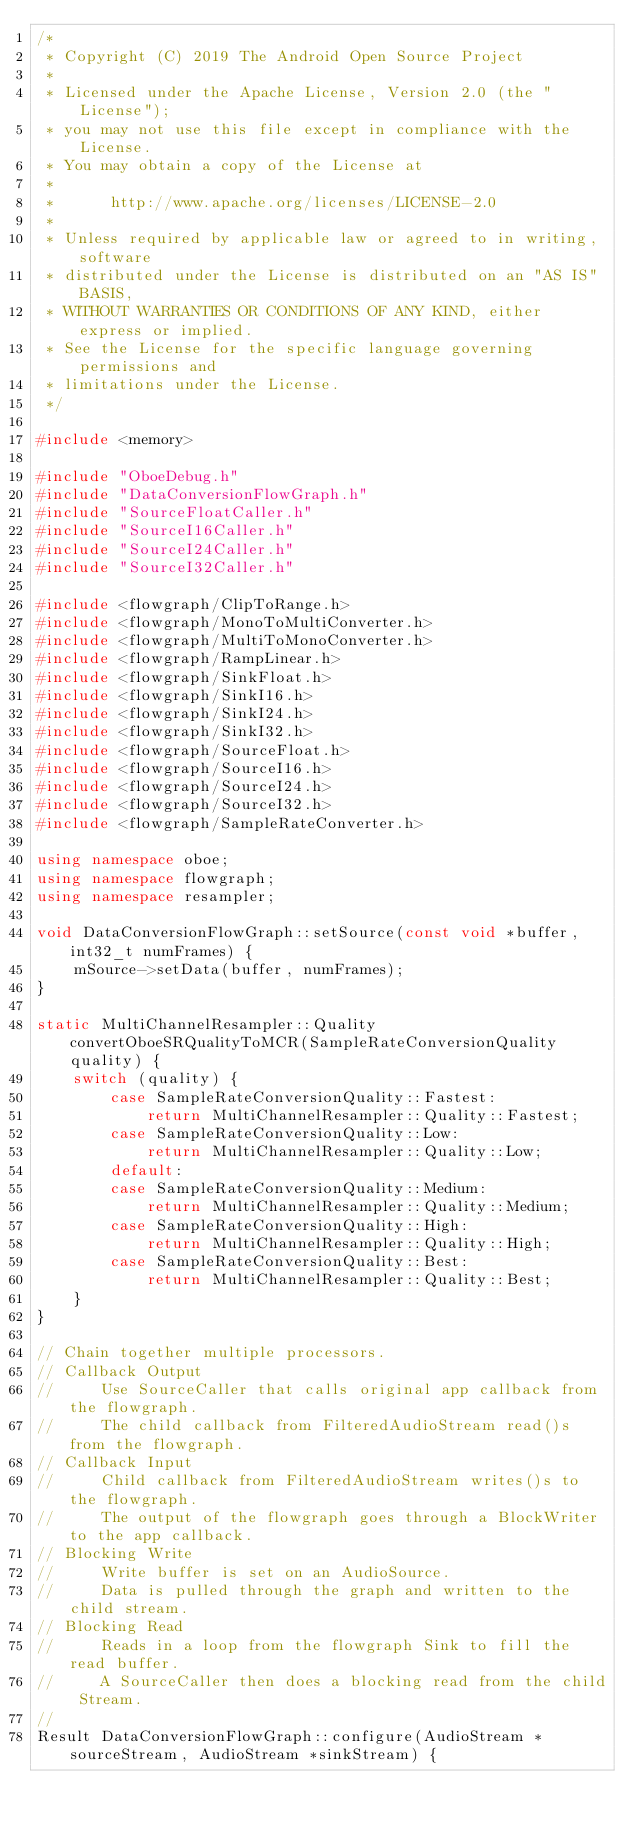<code> <loc_0><loc_0><loc_500><loc_500><_C++_>/*
 * Copyright (C) 2019 The Android Open Source Project
 *
 * Licensed under the Apache License, Version 2.0 (the "License");
 * you may not use this file except in compliance with the License.
 * You may obtain a copy of the License at
 *
 *      http://www.apache.org/licenses/LICENSE-2.0
 *
 * Unless required by applicable law or agreed to in writing, software
 * distributed under the License is distributed on an "AS IS" BASIS,
 * WITHOUT WARRANTIES OR CONDITIONS OF ANY KIND, either express or implied.
 * See the License for the specific language governing permissions and
 * limitations under the License.
 */

#include <memory>

#include "OboeDebug.h"
#include "DataConversionFlowGraph.h"
#include "SourceFloatCaller.h"
#include "SourceI16Caller.h"
#include "SourceI24Caller.h"
#include "SourceI32Caller.h"

#include <flowgraph/ClipToRange.h>
#include <flowgraph/MonoToMultiConverter.h>
#include <flowgraph/MultiToMonoConverter.h>
#include <flowgraph/RampLinear.h>
#include <flowgraph/SinkFloat.h>
#include <flowgraph/SinkI16.h>
#include <flowgraph/SinkI24.h>
#include <flowgraph/SinkI32.h>
#include <flowgraph/SourceFloat.h>
#include <flowgraph/SourceI16.h>
#include <flowgraph/SourceI24.h>
#include <flowgraph/SourceI32.h>
#include <flowgraph/SampleRateConverter.h>

using namespace oboe;
using namespace flowgraph;
using namespace resampler;

void DataConversionFlowGraph::setSource(const void *buffer, int32_t numFrames) {
    mSource->setData(buffer, numFrames);
}

static MultiChannelResampler::Quality convertOboeSRQualityToMCR(SampleRateConversionQuality quality) {
    switch (quality) {
        case SampleRateConversionQuality::Fastest:
            return MultiChannelResampler::Quality::Fastest;
        case SampleRateConversionQuality::Low:
            return MultiChannelResampler::Quality::Low;
        default:
        case SampleRateConversionQuality::Medium:
            return MultiChannelResampler::Quality::Medium;
        case SampleRateConversionQuality::High:
            return MultiChannelResampler::Quality::High;
        case SampleRateConversionQuality::Best:
            return MultiChannelResampler::Quality::Best;
    }
}

// Chain together multiple processors.
// Callback Output
//     Use SourceCaller that calls original app callback from the flowgraph.
//     The child callback from FilteredAudioStream read()s from the flowgraph.
// Callback Input
//     Child callback from FilteredAudioStream writes()s to the flowgraph.
//     The output of the flowgraph goes through a BlockWriter to the app callback.
// Blocking Write
//     Write buffer is set on an AudioSource.
//     Data is pulled through the graph and written to the child stream.
// Blocking Read
//     Reads in a loop from the flowgraph Sink to fill the read buffer.
//     A SourceCaller then does a blocking read from the child Stream.
//
Result DataConversionFlowGraph::configure(AudioStream *sourceStream, AudioStream *sinkStream) {
</code> 